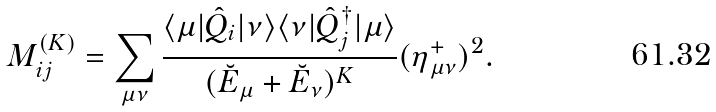Convert formula to latex. <formula><loc_0><loc_0><loc_500><loc_500>M ^ { ( K ) } _ { i j } = \sum _ { \mu \nu } \frac { \langle \mu | \hat { Q } _ { i } | \nu \rangle \langle \nu | \hat { Q } _ { j } ^ { \dagger } | \mu \rangle } { ( \breve { E } _ { \mu } + \breve { E } _ { \nu } ) ^ { K } } ( \eta _ { \mu \nu } ^ { + } ) ^ { 2 } .</formula> 